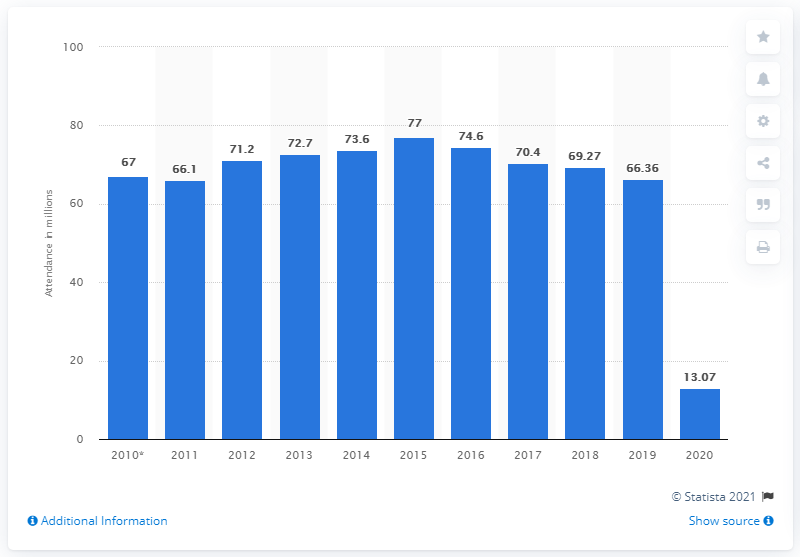Outline some significant characteristics in this image. In 2020, Cineplex was attended by a total of 13,070 people. Approximately 66.36 people visited Cineplex a year earlier. 